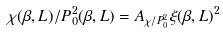Convert formula to latex. <formula><loc_0><loc_0><loc_500><loc_500>\chi ( \beta , L ) / P _ { 0 } ^ { 2 } ( \beta , L ) = A _ { \chi / P _ { 0 } ^ { 2 } } \xi ( \beta , L ) ^ { 2 }</formula> 